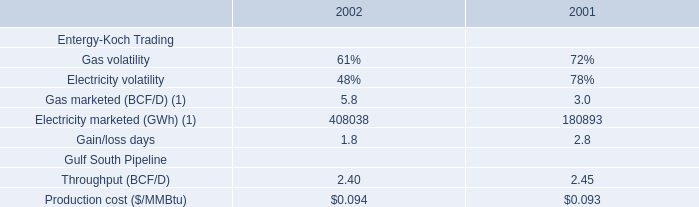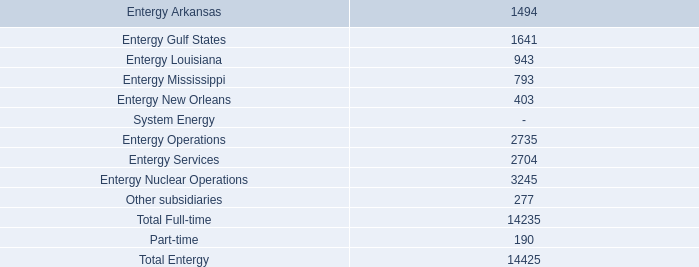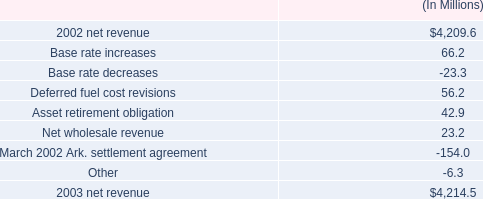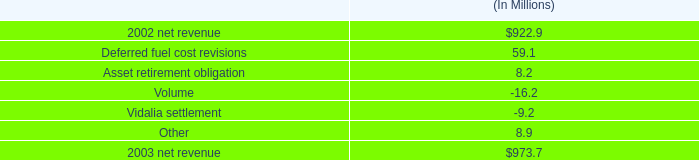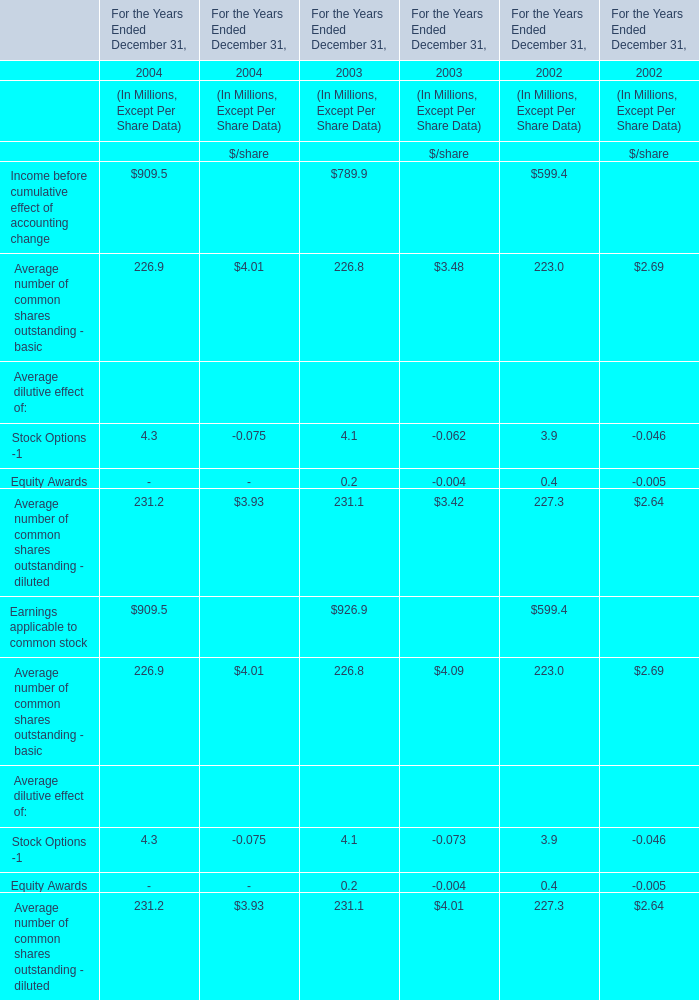What is the ratio of all Average dilutive effect that are smaller than 1.0 to the sum of Average dilutive effect, in 2003? 
Computations: (0.2 / (4.1 + 0.2))
Answer: 0.04651. 